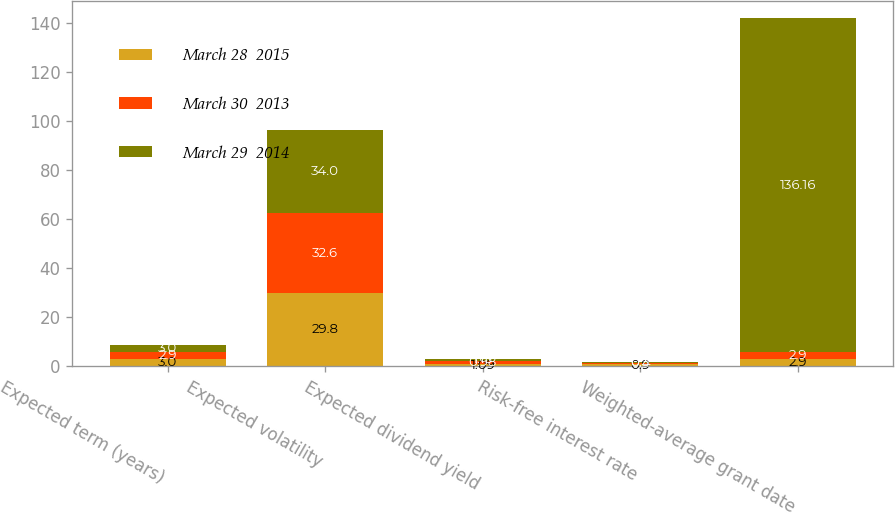<chart> <loc_0><loc_0><loc_500><loc_500><stacked_bar_chart><ecel><fcel>Expected term (years)<fcel>Expected volatility<fcel>Expected dividend yield<fcel>Risk-free interest rate<fcel>Weighted-average grant date<nl><fcel>March 28  2015<fcel>3<fcel>29.8<fcel>1.09<fcel>0.9<fcel>2.9<nl><fcel>March 30  2013<fcel>2.9<fcel>32.6<fcel>0.98<fcel>0.4<fcel>2.9<nl><fcel>March 29  2014<fcel>3<fcel>34<fcel>1.13<fcel>0.3<fcel>136.16<nl></chart> 